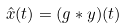<formula> <loc_0><loc_0><loc_500><loc_500>\hat { x } ( t ) = ( g * y ) ( t )</formula> 